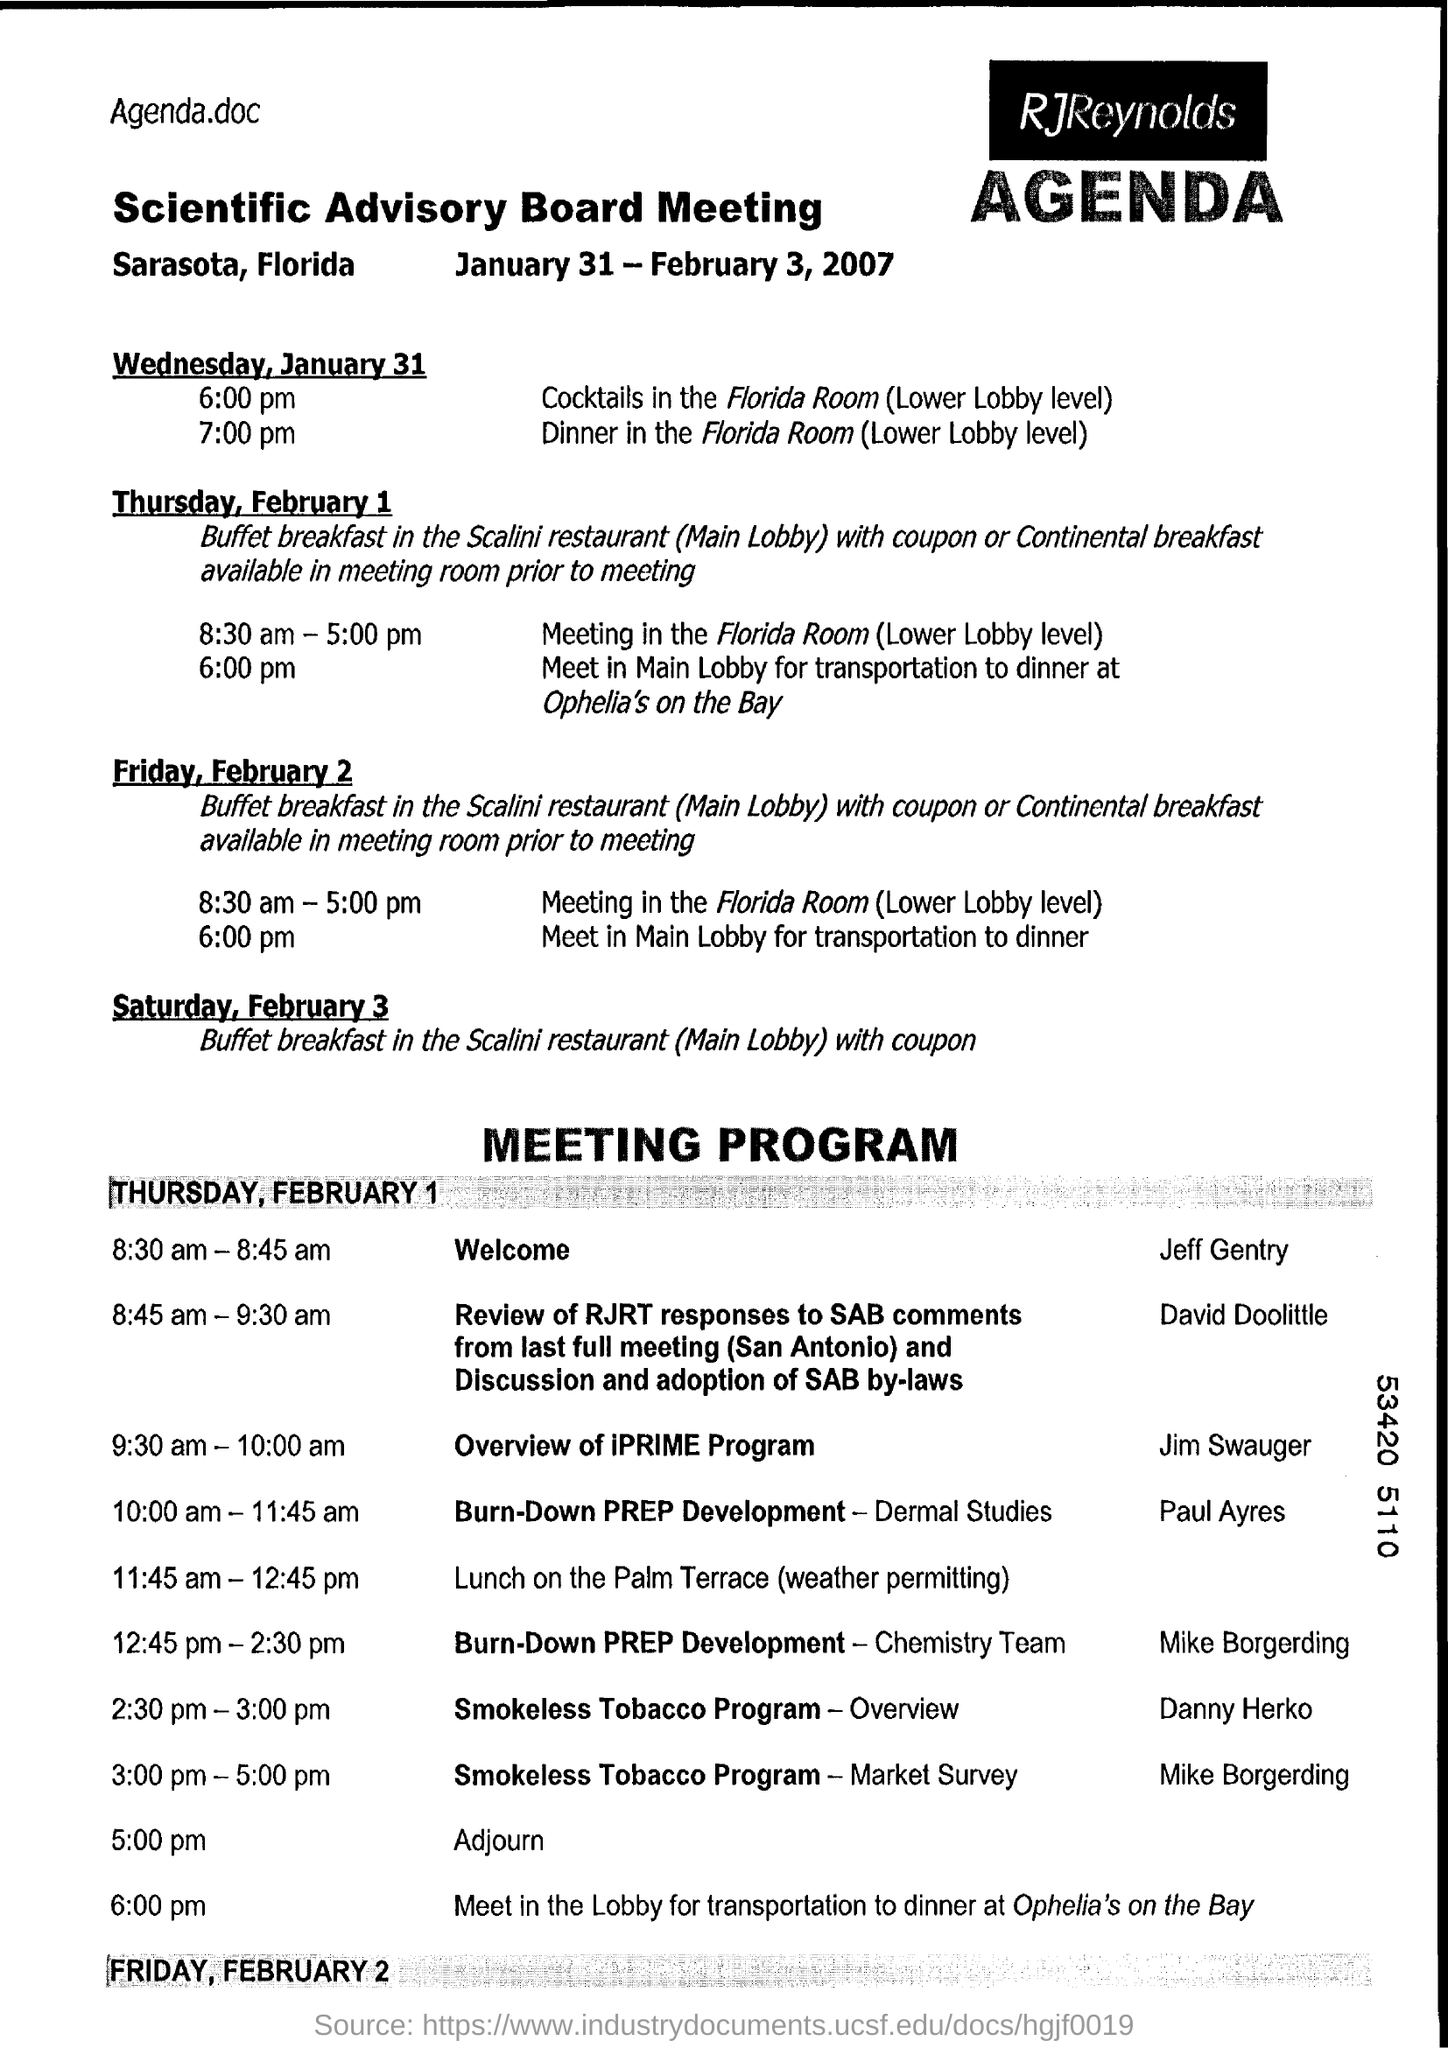Which meeting is this ?
Offer a terse response. Scientific Advisory Board Meeting. Where is the meeting ?
Your response must be concise. Sarasota, Florida. On which date meeting is going to start ?
Keep it short and to the point. January 31. When is the Scientific Advisory Board meeting scheduled?
Offer a terse response. January 31 - February 3, 2007. 